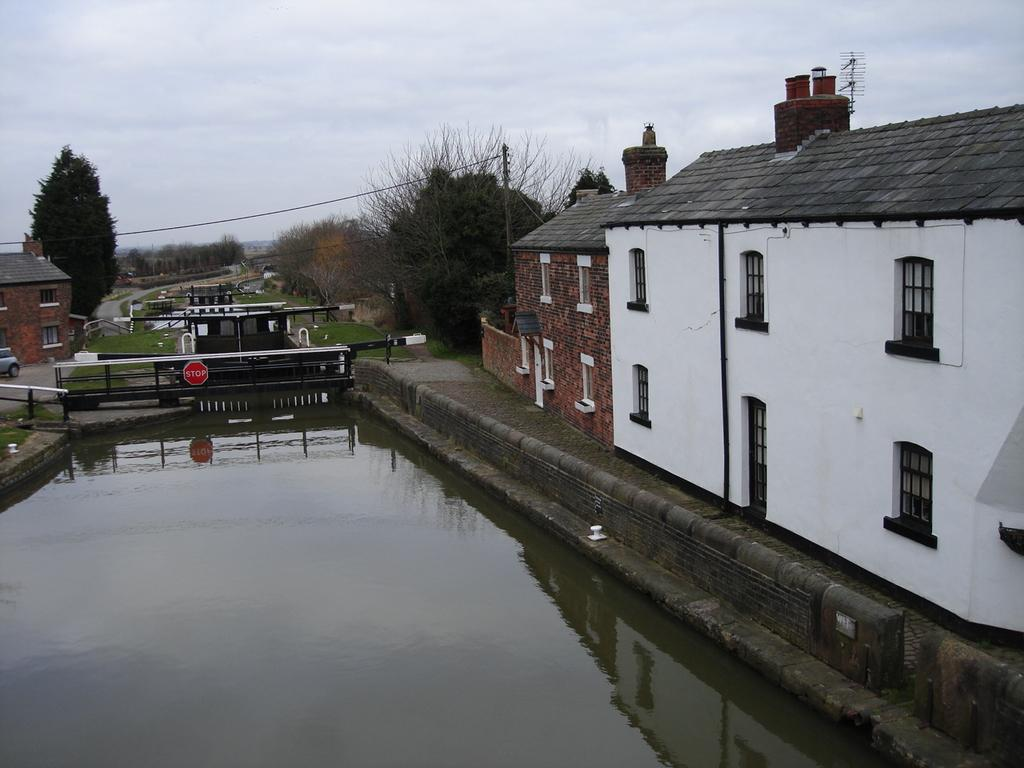What type of structures can be seen in the image? There are buildings in the image. What natural elements are present in the image? There are trees and water visible in the image. What type of transportation is present in the image? There is a car on the side of the image. What type of ground cover is present in the image? There is grass on the ground in the image. What type of man-made object is present in the image? There is an electrical pole in the image. What type of signage is present in the image? There is a sign board for a bridge in the image. How many hands are visible in the image? There are no hands visible in the image. What type of sack is being used to carry the trees in the image? There are no sacks or trees being carried in the image. 